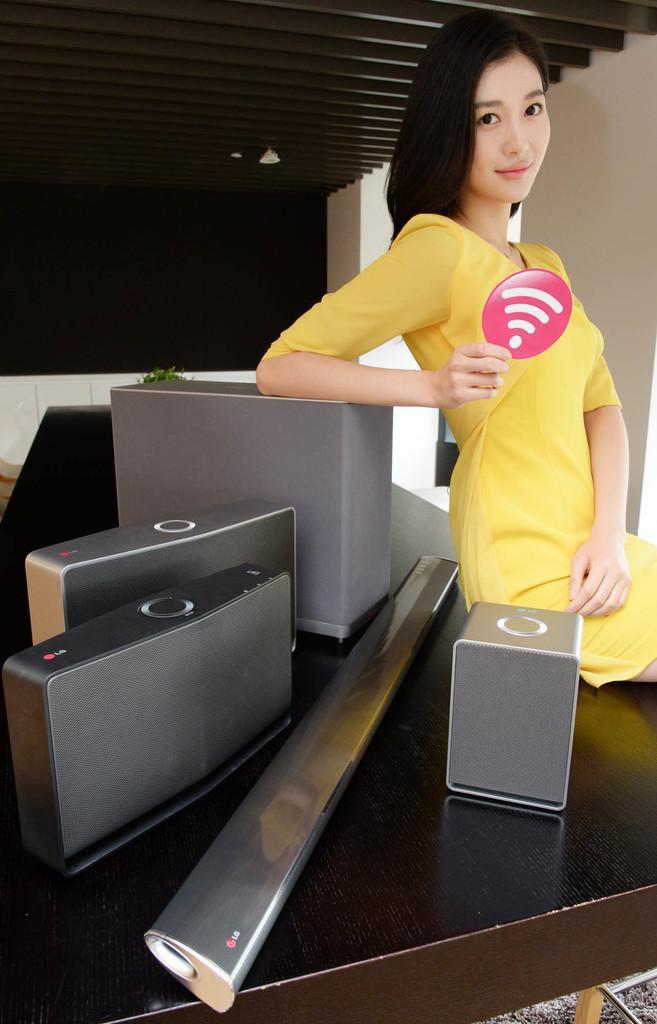Could you give a brief overview of what you see in this image? In the center there is a table,on table we can see chart,box,suitcase,sound box and one lady sitting on the table. And she is smiling,in the background we can see wall and pillar. 